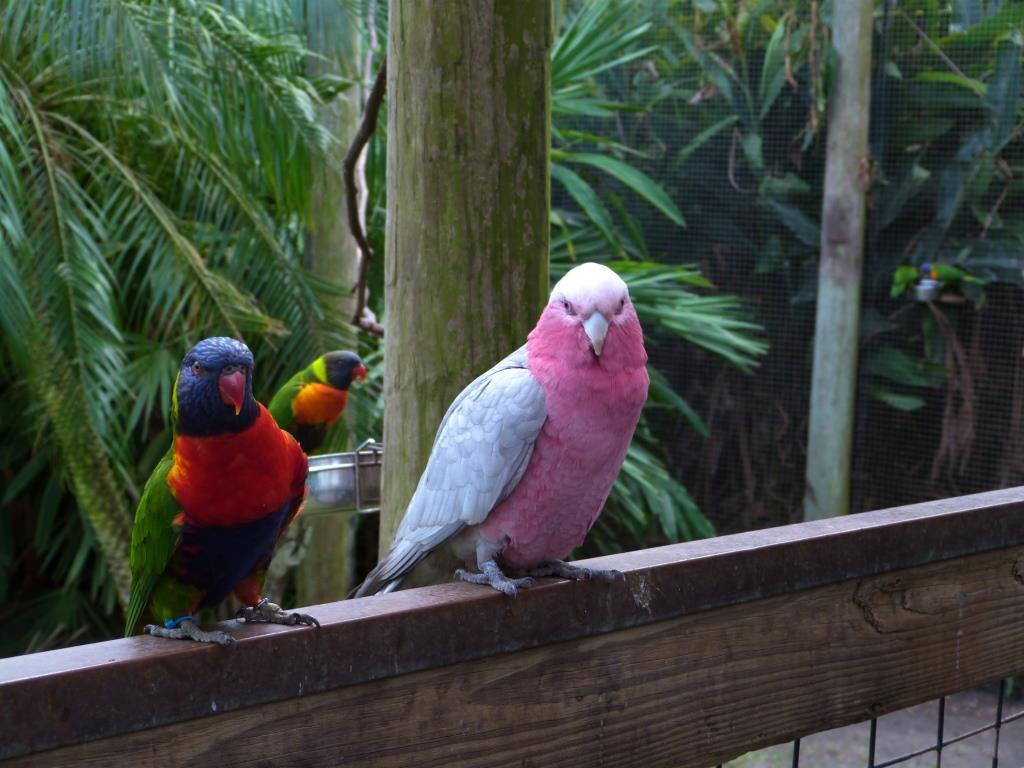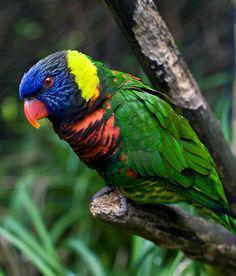The first image is the image on the left, the second image is the image on the right. Examine the images to the left and right. Is the description "Left image contains three parrots, and right image contains one left-facing parrot." accurate? Answer yes or no. Yes. The first image is the image on the left, the second image is the image on the right. Evaluate the accuracy of this statement regarding the images: "Four colorful birds are perched outside.". Is it true? Answer yes or no. Yes. 